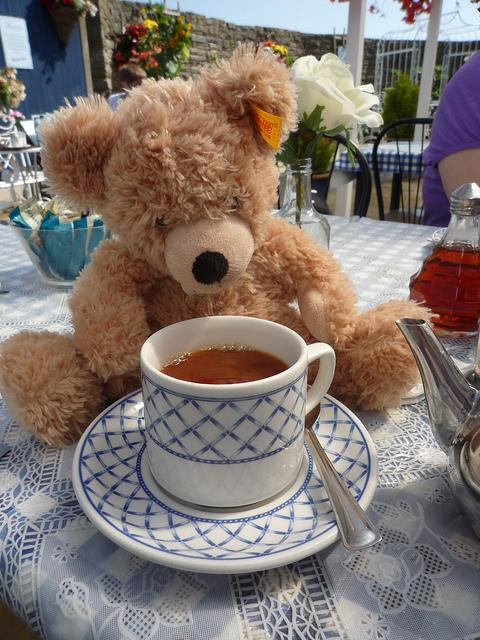Where does the teddy bear come from?

Choices:
A) france
B) germany
C) britain
D) america america 